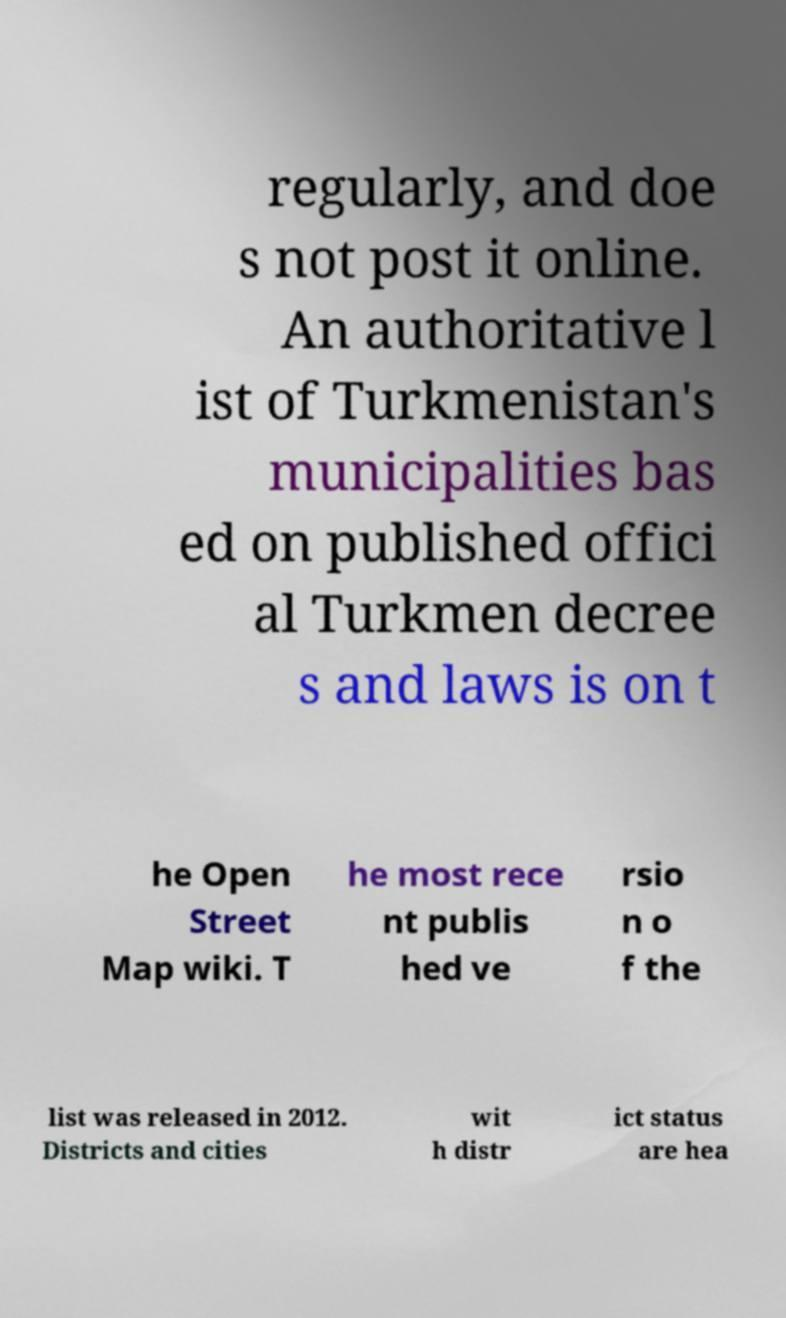What messages or text are displayed in this image? I need them in a readable, typed format. regularly, and doe s not post it online. An authoritative l ist of Turkmenistan's municipalities bas ed on published offici al Turkmen decree s and laws is on t he Open Street Map wiki. T he most rece nt publis hed ve rsio n o f the list was released in 2012. Districts and cities wit h distr ict status are hea 